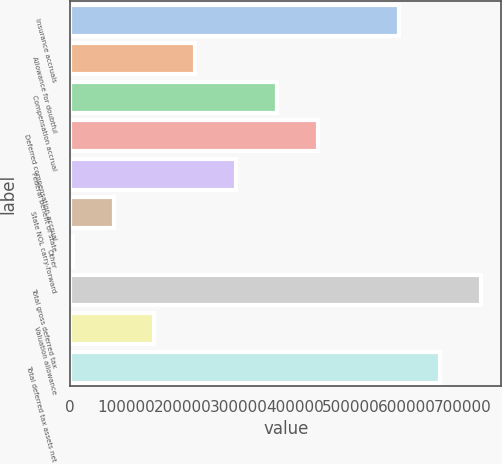Convert chart to OTSL. <chart><loc_0><loc_0><loc_500><loc_500><bar_chart><fcel>Insurance accruals<fcel>Allowance for doubtful<fcel>Compensation accrual<fcel>Deferred compensation accrual<fcel>Federal benefit of state<fcel>State NOL carry-forward<fcel>Other<fcel>Total gross deferred tax<fcel>Valuation allowance<fcel>Total deferred tax assets net<nl><fcel>586402<fcel>222792<fcel>368236<fcel>440958<fcel>295514<fcel>77348<fcel>4626<fcel>731846<fcel>150070<fcel>659124<nl></chart> 